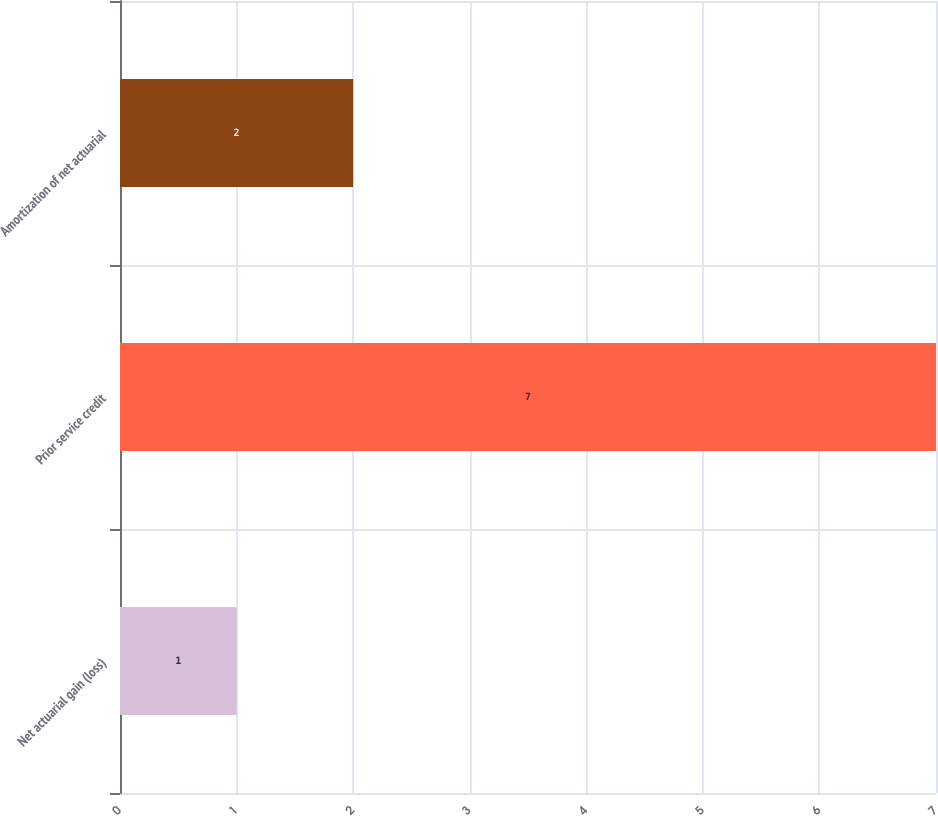Convert chart. <chart><loc_0><loc_0><loc_500><loc_500><bar_chart><fcel>Net actuarial gain (loss)<fcel>Prior service credit<fcel>Amortization of net actuarial<nl><fcel>1<fcel>7<fcel>2<nl></chart> 